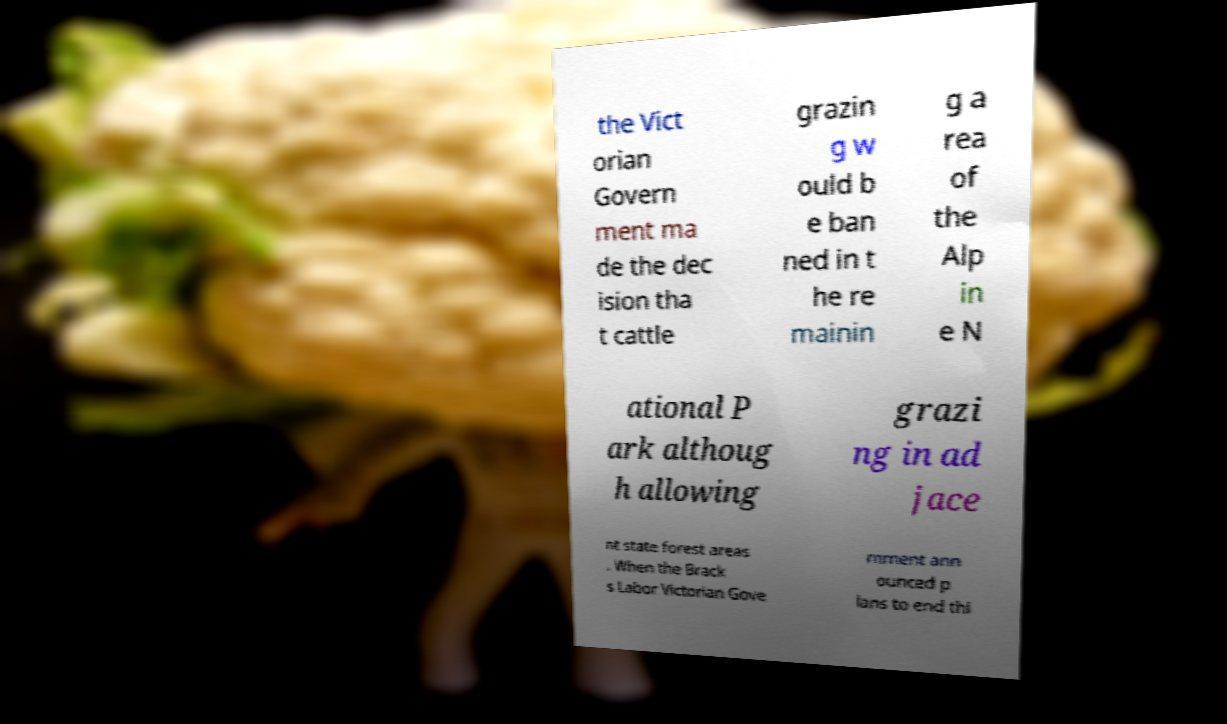Can you read and provide the text displayed in the image?This photo seems to have some interesting text. Can you extract and type it out for me? the Vict orian Govern ment ma de the dec ision tha t cattle grazin g w ould b e ban ned in t he re mainin g a rea of the Alp in e N ational P ark althoug h allowing grazi ng in ad jace nt state forest areas . When the Brack s Labor Victorian Gove rnment ann ounced p lans to end thi 